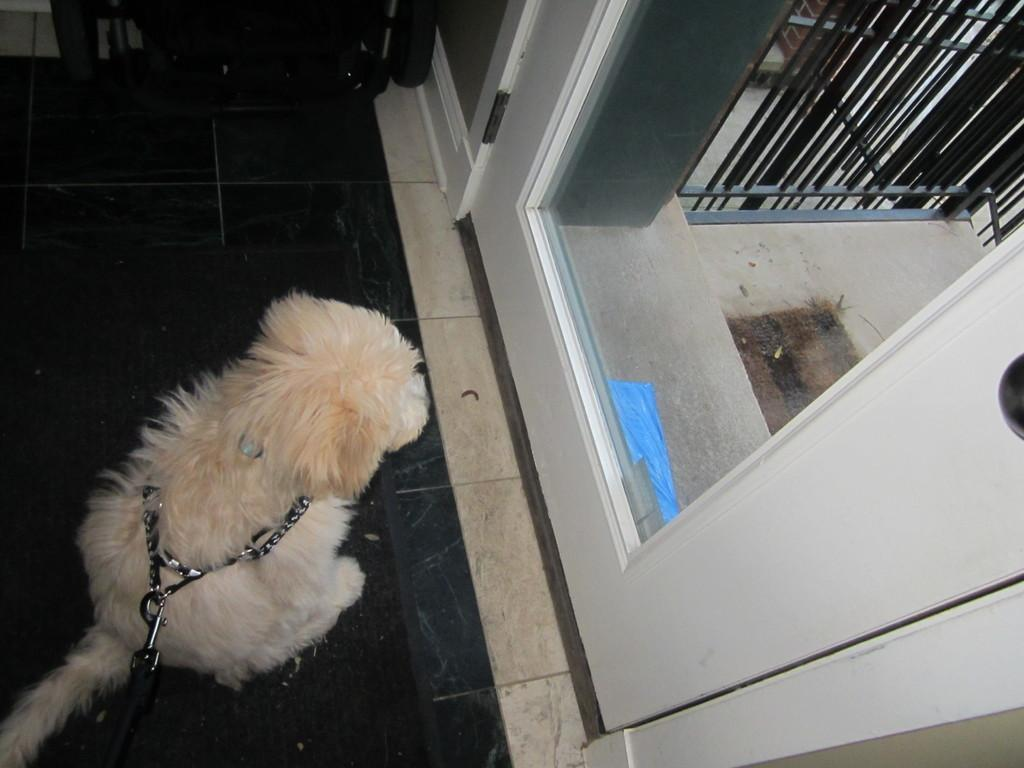What is the main subject in the center of the image? There is a dog in the center of the image. What is the dog wearing? The dog is wearing a chain. What can be seen in the background of the image? There are doors, grills, and some objects in the background of the image. What is the surface on which the dog is standing? There is a floor at the bottom of the image. What type of flowers can be seen in the image? There are no flowers present in the image. What is the governor doing in the image? There is no governor present in the image. 